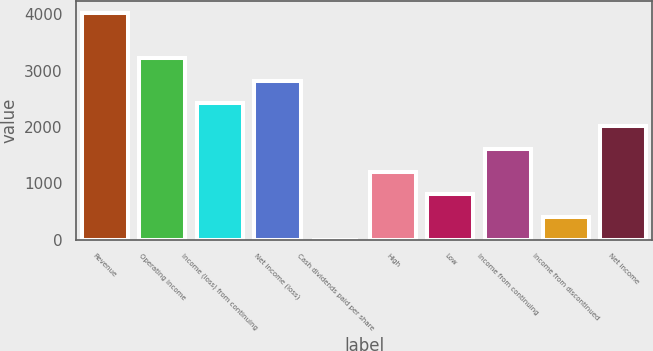<chart> <loc_0><loc_0><loc_500><loc_500><bar_chart><fcel>Revenue<fcel>Operating income<fcel>Income (loss) from continuing<fcel>Net income (loss)<fcel>Cash dividends paid per share<fcel>High<fcel>Low<fcel>Income from continuing<fcel>Income from discontinued<fcel>Net income<nl><fcel>4029<fcel>3223.21<fcel>2417.43<fcel>2820.32<fcel>0.09<fcel>1208.76<fcel>805.87<fcel>1611.65<fcel>402.98<fcel>2014.54<nl></chart> 